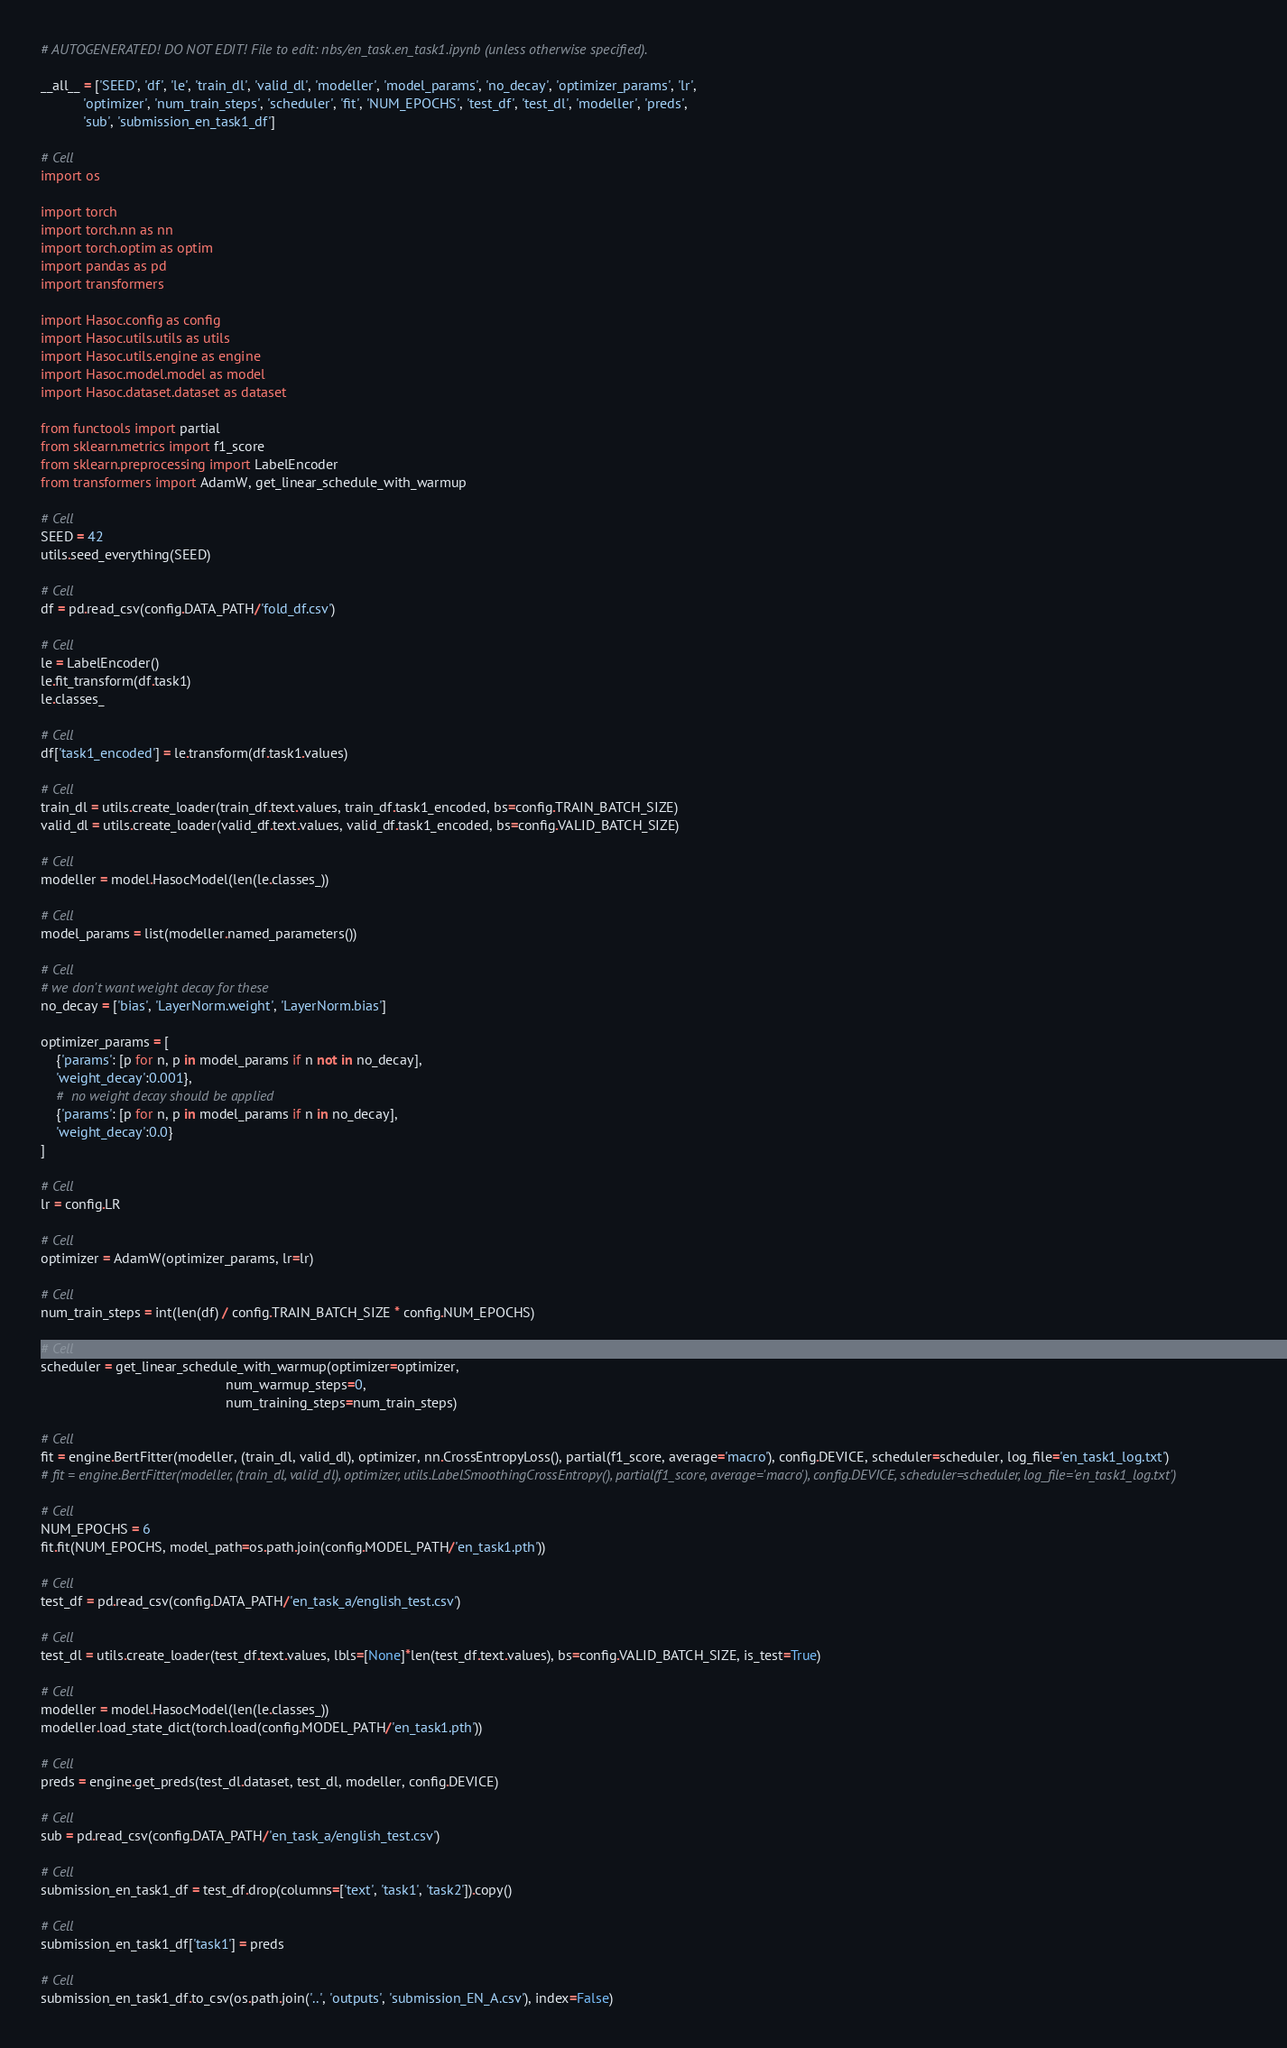<code> <loc_0><loc_0><loc_500><loc_500><_Python_># AUTOGENERATED! DO NOT EDIT! File to edit: nbs/en_task.en_task1.ipynb (unless otherwise specified).

__all__ = ['SEED', 'df', 'le', 'train_dl', 'valid_dl', 'modeller', 'model_params', 'no_decay', 'optimizer_params', 'lr',
           'optimizer', 'num_train_steps', 'scheduler', 'fit', 'NUM_EPOCHS', 'test_df', 'test_dl', 'modeller', 'preds',
           'sub', 'submission_en_task1_df']

# Cell
import os

import torch
import torch.nn as nn
import torch.optim as optim
import pandas as pd
import transformers

import Hasoc.config as config
import Hasoc.utils.utils as utils
import Hasoc.utils.engine as engine
import Hasoc.model.model as model
import Hasoc.dataset.dataset as dataset

from functools import partial
from sklearn.metrics import f1_score
from sklearn.preprocessing import LabelEncoder
from transformers import AdamW, get_linear_schedule_with_warmup

# Cell
SEED = 42
utils.seed_everything(SEED)

# Cell
df = pd.read_csv(config.DATA_PATH/'fold_df.csv')

# Cell
le = LabelEncoder()
le.fit_transform(df.task1)
le.classes_

# Cell
df['task1_encoded'] = le.transform(df.task1.values)

# Cell
train_dl = utils.create_loader(train_df.text.values, train_df.task1_encoded, bs=config.TRAIN_BATCH_SIZE)
valid_dl = utils.create_loader(valid_df.text.values, valid_df.task1_encoded, bs=config.VALID_BATCH_SIZE)

# Cell
modeller = model.HasocModel(len(le.classes_))

# Cell
model_params = list(modeller.named_parameters())

# Cell
# we don't want weight decay for these
no_decay = ['bias', 'LayerNorm.weight', 'LayerNorm.bias']

optimizer_params = [
    {'params': [p for n, p in model_params if n not in no_decay],
    'weight_decay':0.001},
    #  no weight decay should be applied
    {'params': [p for n, p in model_params if n in no_decay],
    'weight_decay':0.0}
]

# Cell
lr = config.LR

# Cell
optimizer = AdamW(optimizer_params, lr=lr)

# Cell
num_train_steps = int(len(df) / config.TRAIN_BATCH_SIZE * config.NUM_EPOCHS)

# Cell
scheduler = get_linear_schedule_with_warmup(optimizer=optimizer,
                                                num_warmup_steps=0,
                                                num_training_steps=num_train_steps)

# Cell
fit = engine.BertFitter(modeller, (train_dl, valid_dl), optimizer, nn.CrossEntropyLoss(), partial(f1_score, average='macro'), config.DEVICE, scheduler=scheduler, log_file='en_task1_log.txt')
# fit = engine.BertFitter(modeller, (train_dl, valid_dl), optimizer, utils.LabelSmoothingCrossEntropy(), partial(f1_score, average='macro'), config.DEVICE, scheduler=scheduler, log_file='en_task1_log.txt')

# Cell
NUM_EPOCHS = 6
fit.fit(NUM_EPOCHS, model_path=os.path.join(config.MODEL_PATH/'en_task1.pth'))

# Cell
test_df = pd.read_csv(config.DATA_PATH/'en_task_a/english_test.csv')

# Cell
test_dl = utils.create_loader(test_df.text.values, lbls=[None]*len(test_df.text.values), bs=config.VALID_BATCH_SIZE, is_test=True)

# Cell
modeller = model.HasocModel(len(le.classes_))
modeller.load_state_dict(torch.load(config.MODEL_PATH/'en_task1.pth'))

# Cell
preds = engine.get_preds(test_dl.dataset, test_dl, modeller, config.DEVICE)

# Cell
sub = pd.read_csv(config.DATA_PATH/'en_task_a/english_test.csv')

# Cell
submission_en_task1_df = test_df.drop(columns=['text', 'task1', 'task2']).copy()

# Cell
submission_en_task1_df['task1'] = preds

# Cell
submission_en_task1_df.to_csv(os.path.join('..', 'outputs', 'submission_EN_A.csv'), index=False)</code> 